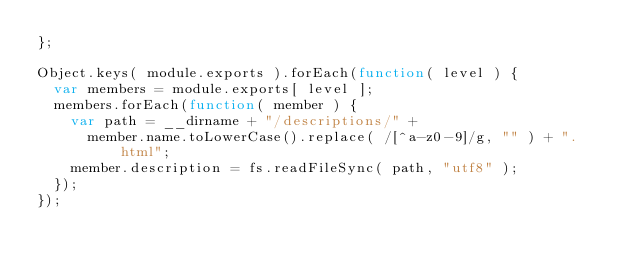<code> <loc_0><loc_0><loc_500><loc_500><_JavaScript_>};

Object.keys( module.exports ).forEach(function( level ) {
	var members = module.exports[ level ];
	members.forEach(function( member ) {
		var path = __dirname + "/descriptions/" +
			member.name.toLowerCase().replace( /[^a-z0-9]/g, "" ) + ".html";
		member.description = fs.readFileSync( path, "utf8" );
	});
});
</code> 